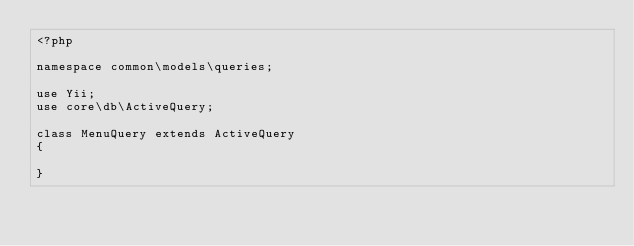Convert code to text. <code><loc_0><loc_0><loc_500><loc_500><_PHP_><?php

namespace common\models\queries;

use Yii;
use core\db\ActiveQuery;

class MenuQuery extends ActiveQuery
{
    
}</code> 